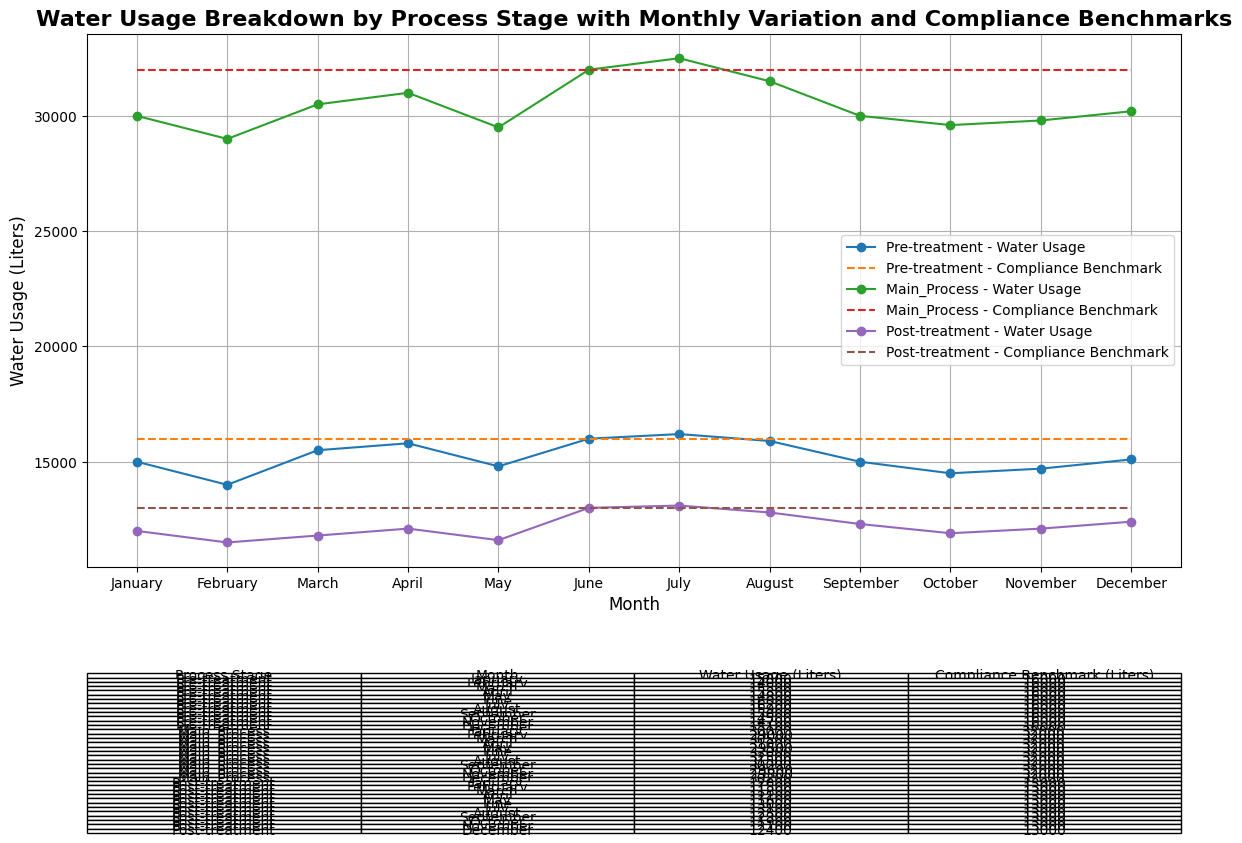What is the total water usage for Pre-treatment in the first quarter (January to March)? To find the total water usage for Pre-treatment in the first quarter, add the water usage for January, February, and March. This amounts to: 15000 + 14000 + 15500 = 44500 liters.
Answer: 44500 liters Which process stage had the highest water usage in July? To determine the highest water usage in July, compare the water usage values for Pre-treatment, Main Process, and Post-treatment for that month: 16200 (Pre-treatment), 32500 (Main Process), 13100 (Post-treatment). The Main Process had the highest water usage at 32500 liters.
Answer: Main Process Did any process stage exceed its compliance benchmark in June? Compare the water usage for each process stage in June to their respective compliance benchmarks: 16000 (Pre-treatment) vs. 16000 (benchmark), 32000 (Main Process) vs. 32000 (benchmark), 13000 (Post-treatment) vs. 13000 (benchmark). None of the stages exceeded their benchmarks in June.
Answer: No What is the average water usage for Main Process over the year? To find the average, sum the monthly water usage values for Main Process and divide by 12: (30000 + 29000 + 30500 + 31000 + 29500 + 32000 + 32500 + 31500 + 30000 + 29600 + 29800 + 30200) / 12 = 315600 / 12 = 26300 liters.
Answer: 26300 liters Which month had the lowest water usage for Post-treatment, and what was the value? To find the month with the lowest water usage for Post-treatment, scan the values for each month and identify the minimum: January (12000), February (11500), March (11800), April (12100), May (11600), June (13000), July (13100), August (12800), September (12300), October (11900), November (12100), December (12400). The lowest water usage was in February with 11500 liters.
Answer: February, 11500 liters Did the Pre-treatment process ever exceed its compliance benchmark? To determine whether Pre-treatment exceeded its compliance benchmark at any point, compare the water usage values to the benchmark (16000 liters) month by month: In July, it had 16200 liters, exceeding the benchmark.
Answer: Yes What is the difference in water usage between Pre-treatment and Main Process in March? Find the water usage for each process in March and subtract the Pre-treatment value from the Main Process value: 30500 (Main Process) - 15500 (Pre-treatment) = 15000 liters.
Answer: 15000 liters How did the water usage for Main Process compare between January and December? Compare the water usage for Main Process in January (30000 liters) and in December (30200 liters). The difference is 30200 - 30000 = 200 liters. The water usage increased by 200 liters from January to December.
Answer: Increased by 200 liters What was the highest compliance benchmark among all process stages and months? Look at the compliance benchmarks for all process stages and months to identify the highest value. The highest benchmarks are consistently 32000 liters for the Main Process for every month.
Answer: 32000 liters 